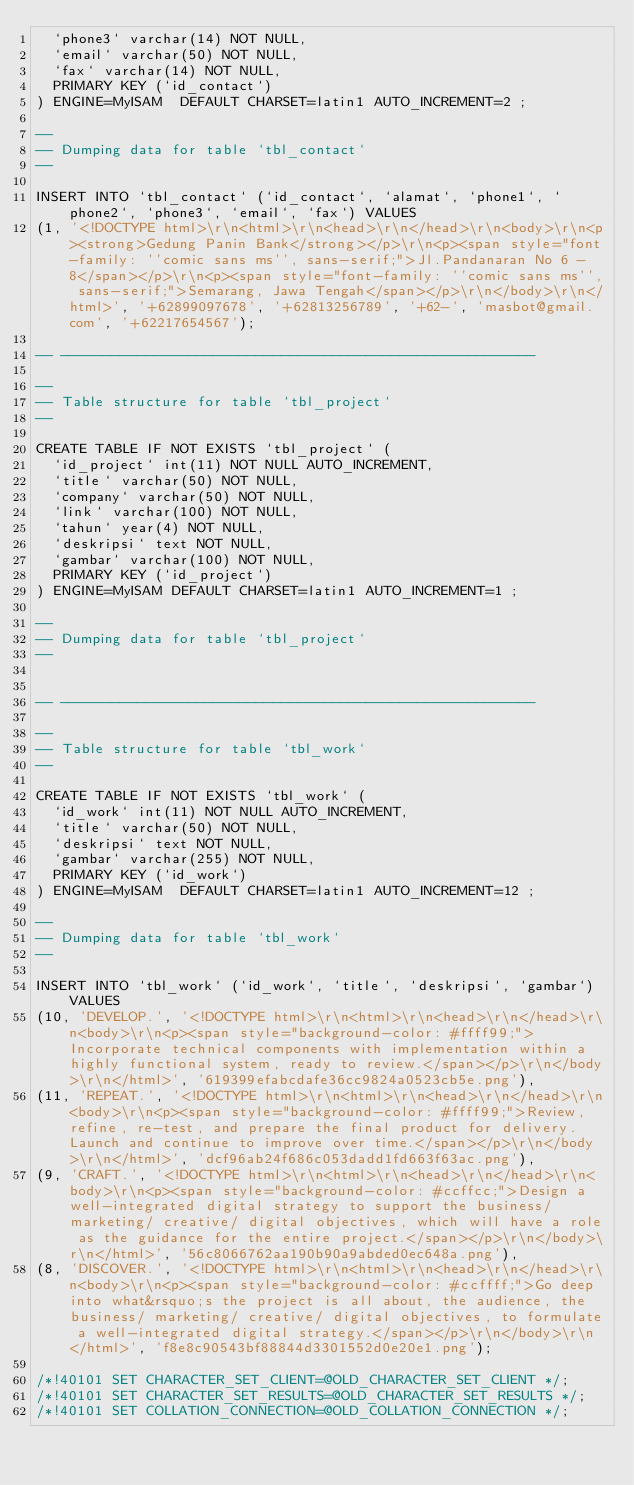Convert code to text. <code><loc_0><loc_0><loc_500><loc_500><_SQL_>  `phone3` varchar(14) NOT NULL,
  `email` varchar(50) NOT NULL,
  `fax` varchar(14) NOT NULL,
  PRIMARY KEY (`id_contact`)
) ENGINE=MyISAM  DEFAULT CHARSET=latin1 AUTO_INCREMENT=2 ;

--
-- Dumping data for table `tbl_contact`
--

INSERT INTO `tbl_contact` (`id_contact`, `alamat`, `phone1`, `phone2`, `phone3`, `email`, `fax`) VALUES
(1, '<!DOCTYPE html>\r\n<html>\r\n<head>\r\n</head>\r\n<body>\r\n<p><strong>Gedung Panin Bank</strong></p>\r\n<p><span style="font-family: ''comic sans ms'', sans-serif;">Jl.Pandanaran No 6 - 8</span></p>\r\n<p><span style="font-family: ''comic sans ms'', sans-serif;">Semarang, Jawa Tengah</span></p>\r\n</body>\r\n</html>', '+62899097678', '+62813256789', '+62-', 'masbot@gmail.com', '+62217654567');

-- --------------------------------------------------------

--
-- Table structure for table `tbl_project`
--

CREATE TABLE IF NOT EXISTS `tbl_project` (
  `id_project` int(11) NOT NULL AUTO_INCREMENT,
  `title` varchar(50) NOT NULL,
  `company` varchar(50) NOT NULL,
  `link` varchar(100) NOT NULL,
  `tahun` year(4) NOT NULL,
  `deskripsi` text NOT NULL,
  `gambar` varchar(100) NOT NULL,
  PRIMARY KEY (`id_project`)
) ENGINE=MyISAM DEFAULT CHARSET=latin1 AUTO_INCREMENT=1 ;

--
-- Dumping data for table `tbl_project`
--


-- --------------------------------------------------------

--
-- Table structure for table `tbl_work`
--

CREATE TABLE IF NOT EXISTS `tbl_work` (
  `id_work` int(11) NOT NULL AUTO_INCREMENT,
  `title` varchar(50) NOT NULL,
  `deskripsi` text NOT NULL,
  `gambar` varchar(255) NOT NULL,
  PRIMARY KEY (`id_work`)
) ENGINE=MyISAM  DEFAULT CHARSET=latin1 AUTO_INCREMENT=12 ;

--
-- Dumping data for table `tbl_work`
--

INSERT INTO `tbl_work` (`id_work`, `title`, `deskripsi`, `gambar`) VALUES
(10, 'DEVELOP.', '<!DOCTYPE html>\r\n<html>\r\n<head>\r\n</head>\r\n<body>\r\n<p><span style="background-color: #ffff99;">Incorporate technical components with implementation within a highly functional system, ready to review.</span></p>\r\n</body>\r\n</html>', '619399efabcdafe36cc9824a0523cb5e.png'),
(11, 'REPEAT.', '<!DOCTYPE html>\r\n<html>\r\n<head>\r\n</head>\r\n<body>\r\n<p><span style="background-color: #ffff99;">Review, refine, re-test, and prepare the final product for delivery. Launch and continue to improve over time.</span></p>\r\n</body>\r\n</html>', 'dcf96ab24f686c053dadd1fd663f63ac.png'),
(9, 'CRAFT.', '<!DOCTYPE html>\r\n<html>\r\n<head>\r\n</head>\r\n<body>\r\n<p><span style="background-color: #ccffcc;">Design a well-integrated digital strategy to support the business/ marketing/ creative/ digital objectives, which will have a role as the guidance for the entire project.</span></p>\r\n</body>\r\n</html>', '56c8066762aa190b90a9abded0ec648a.png'),
(8, 'DISCOVER.', '<!DOCTYPE html>\r\n<html>\r\n<head>\r\n</head>\r\n<body>\r\n<p><span style="background-color: #ccffff;">Go deep into what&rsquo;s the project is all about, the audience, the business/ marketing/ creative/ digital objectives, to formulate a well-integrated digital strategy.</span></p>\r\n</body>\r\n</html>', 'f8e8c90543bf88844d3301552d0e20e1.png');

/*!40101 SET CHARACTER_SET_CLIENT=@OLD_CHARACTER_SET_CLIENT */;
/*!40101 SET CHARACTER_SET_RESULTS=@OLD_CHARACTER_SET_RESULTS */;
/*!40101 SET COLLATION_CONNECTION=@OLD_COLLATION_CONNECTION */;
</code> 